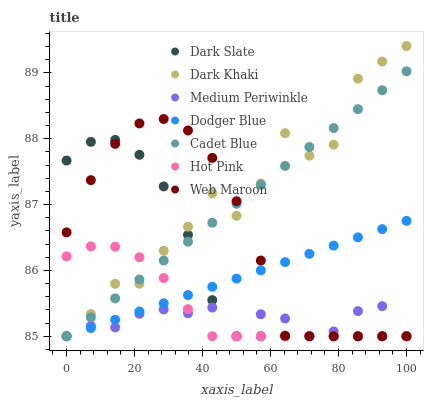Does Medium Periwinkle have the minimum area under the curve?
Answer yes or no. Yes. Does Dark Khaki have the maximum area under the curve?
Answer yes or no. Yes. Does Web Maroon have the minimum area under the curve?
Answer yes or no. No. Does Web Maroon have the maximum area under the curve?
Answer yes or no. No. Is Dodger Blue the smoothest?
Answer yes or no. Yes. Is Dark Khaki the roughest?
Answer yes or no. Yes. Is Web Maroon the smoothest?
Answer yes or no. No. Is Web Maroon the roughest?
Answer yes or no. No. Does Cadet Blue have the lowest value?
Answer yes or no. Yes. Does Dark Khaki have the highest value?
Answer yes or no. Yes. Does Web Maroon have the highest value?
Answer yes or no. No. Does Hot Pink intersect Cadet Blue?
Answer yes or no. Yes. Is Hot Pink less than Cadet Blue?
Answer yes or no. No. Is Hot Pink greater than Cadet Blue?
Answer yes or no. No. 